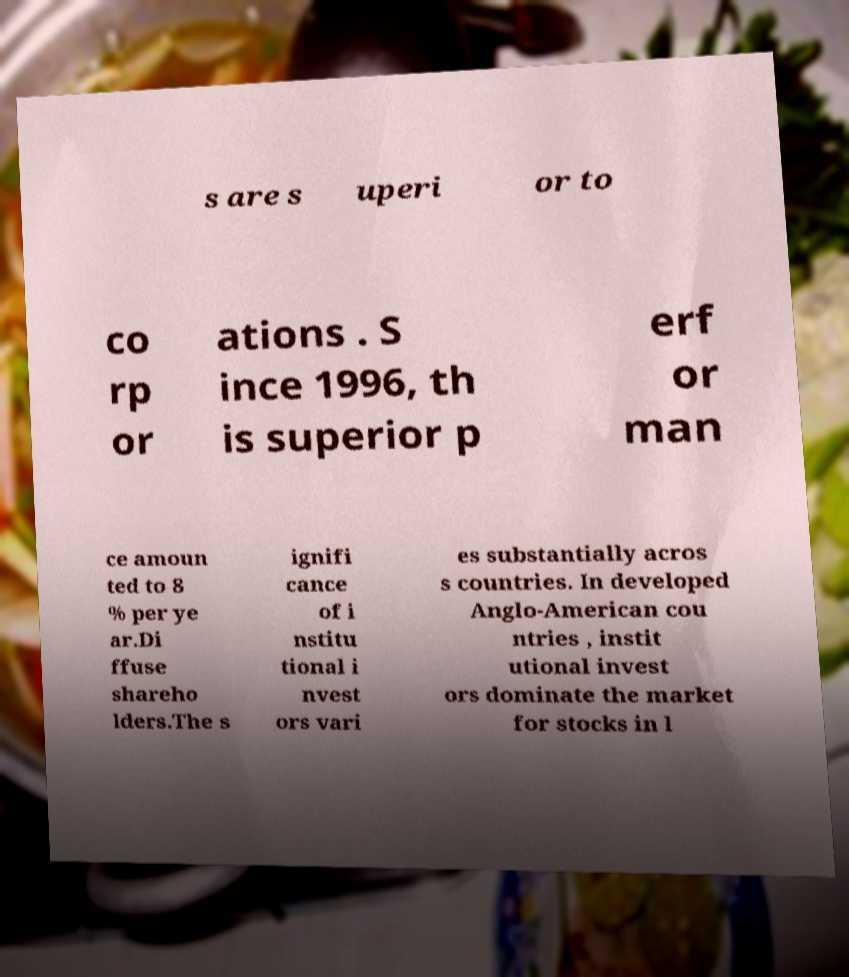Please read and relay the text visible in this image. What does it say? s are s uperi or to co rp or ations . S ince 1996, th is superior p erf or man ce amoun ted to 8 % per ye ar.Di ffuse shareho lders.The s ignifi cance of i nstitu tional i nvest ors vari es substantially acros s countries. In developed Anglo-American cou ntries , instit utional invest ors dominate the market for stocks in l 